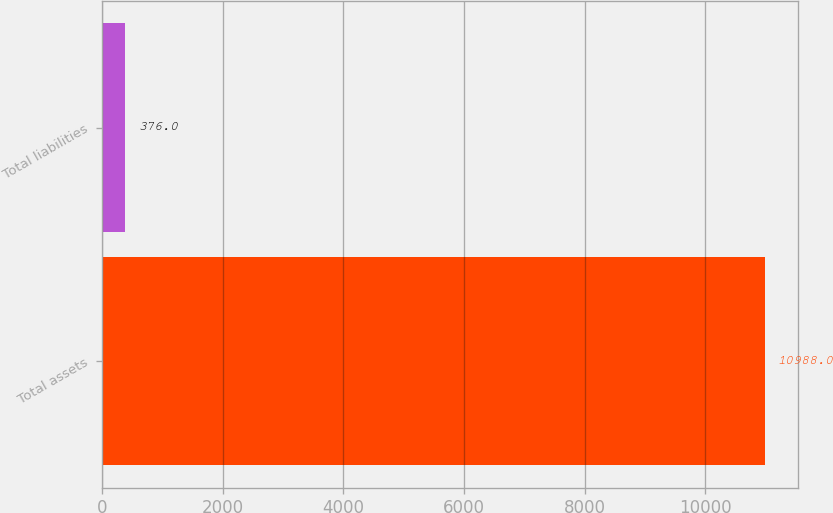Convert chart. <chart><loc_0><loc_0><loc_500><loc_500><bar_chart><fcel>Total assets<fcel>Total liabilities<nl><fcel>10988<fcel>376<nl></chart> 